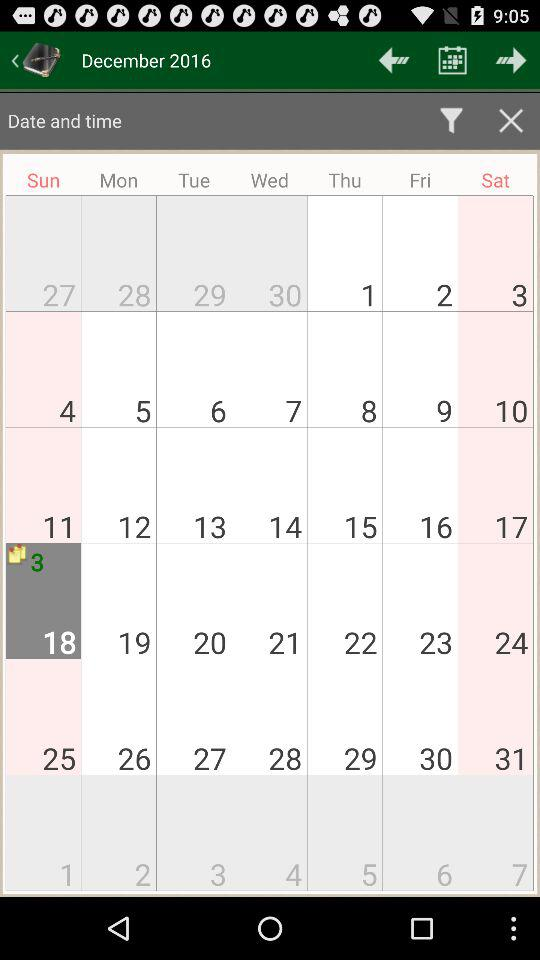Which date is selected on the screen? The selected date on the screen is December 18, 2016. 